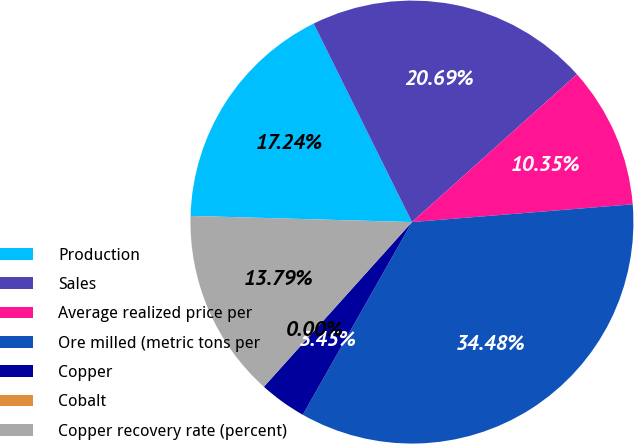<chart> <loc_0><loc_0><loc_500><loc_500><pie_chart><fcel>Production<fcel>Sales<fcel>Average realized price per<fcel>Ore milled (metric tons per<fcel>Copper<fcel>Cobalt<fcel>Copper recovery rate (percent)<nl><fcel>17.24%<fcel>20.69%<fcel>10.35%<fcel>34.48%<fcel>3.45%<fcel>0.0%<fcel>13.79%<nl></chart> 